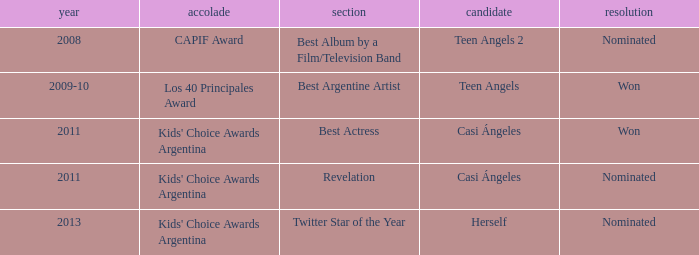Could you parse the entire table as a dict? {'header': ['year', 'accolade', 'section', 'candidate', 'resolution'], 'rows': [['2008', 'CAPIF Award', 'Best Album by a Film/Television Band', 'Teen Angels 2', 'Nominated'], ['2009-10', 'Los 40 Principales Award', 'Best Argentine Artist', 'Teen Angels', 'Won'], ['2011', "Kids' Choice Awards Argentina", 'Best Actress', 'Casi Ángeles', 'Won'], ['2011', "Kids' Choice Awards Argentina", 'Revelation', 'Casi Ángeles', 'Nominated'], ['2013', "Kids' Choice Awards Argentina", 'Twitter Star of the Year', 'Herself', 'Nominated']]} In which year was teen angels 2 nominated? 2008.0. 